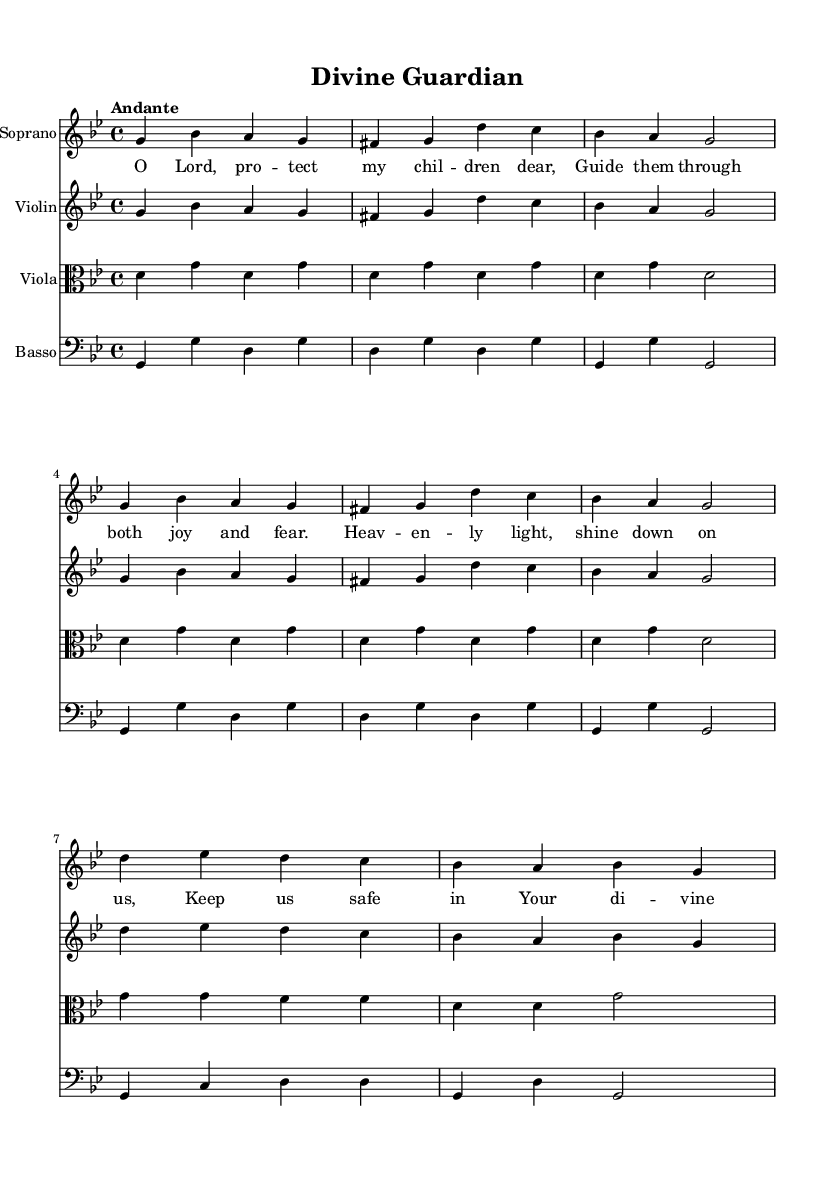What is the key signature of this music? The key signature has two flats, indicating it is in G minor.
Answer: G minor What is the time signature of the piece? The time signature is 4/4, which means there are four beats in each measure.
Answer: 4/4 What is the tempo marking for this composition? The tempo marking indicates "Andante," which refers to a moderate walking pace of speed.
Answer: Andante How many staves are present in the score? The score includes four staves for the soprano, violin, viola, and basso continuo.
Answer: Four What themes are reflected in the lyrics of this piece? The lyrics express themes of protection and divine guidance for the children, referencing safety and heavenly light.
Answer: Protection and divine guidance What is the form of this piece based on the structure? The structure consists of an introduction, verse 1, and a chorus, which is typical in religious Baroque music for emphasizing the message.
Answer: Introduction, Verse, Chorus What instrument accompanies the soprano part in the score? The violin part accompanies the soprano, playing a simplified harmonic line beneath it.
Answer: Violin 